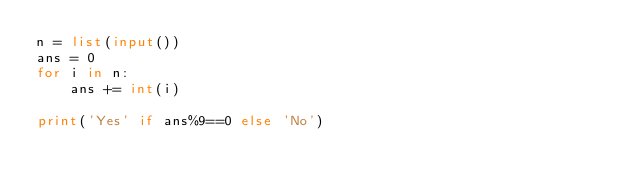<code> <loc_0><loc_0><loc_500><loc_500><_Python_>n = list(input())
ans = 0
for i in n:
    ans += int(i)

print('Yes' if ans%9==0 else 'No')
</code> 